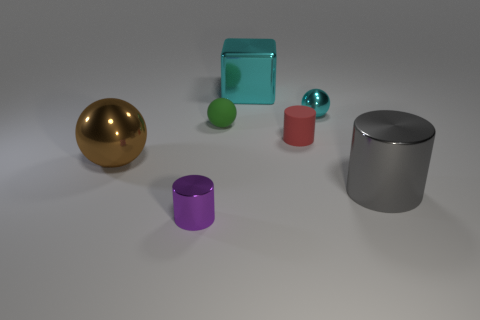There is a small ball that is behind the small green object; is it the same color as the shiny cube?
Your response must be concise. Yes. Does the big metal cube have the same color as the small metal object that is behind the gray metallic cylinder?
Your response must be concise. Yes. There is a tiny green matte object that is on the left side of the red object; does it have the same shape as the big cyan thing?
Offer a terse response. No. How many shiny balls are the same size as the gray cylinder?
Your response must be concise. 1. What number of yellow things are either tiny rubber cylinders or big metal objects?
Keep it short and to the point. 0. How many objects are rubber balls or metallic objects that are right of the purple thing?
Your answer should be compact. 4. What is the material of the small cylinder behind the purple shiny object?
Give a very brief answer. Rubber. There is a cyan shiny thing that is the same size as the brown metallic object; what is its shape?
Provide a short and direct response. Cube. Is there a large metal object of the same shape as the small cyan metal thing?
Your answer should be very brief. Yes. Does the cyan ball have the same material as the large cube that is right of the small purple thing?
Give a very brief answer. Yes. 